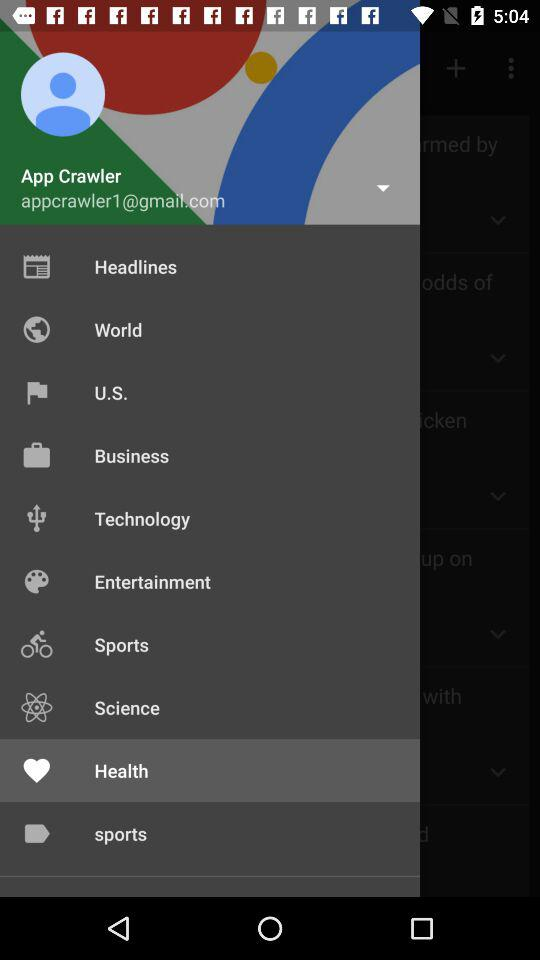What's the Google mail address? The Google mail address is appcrawler1@gmail.com. 